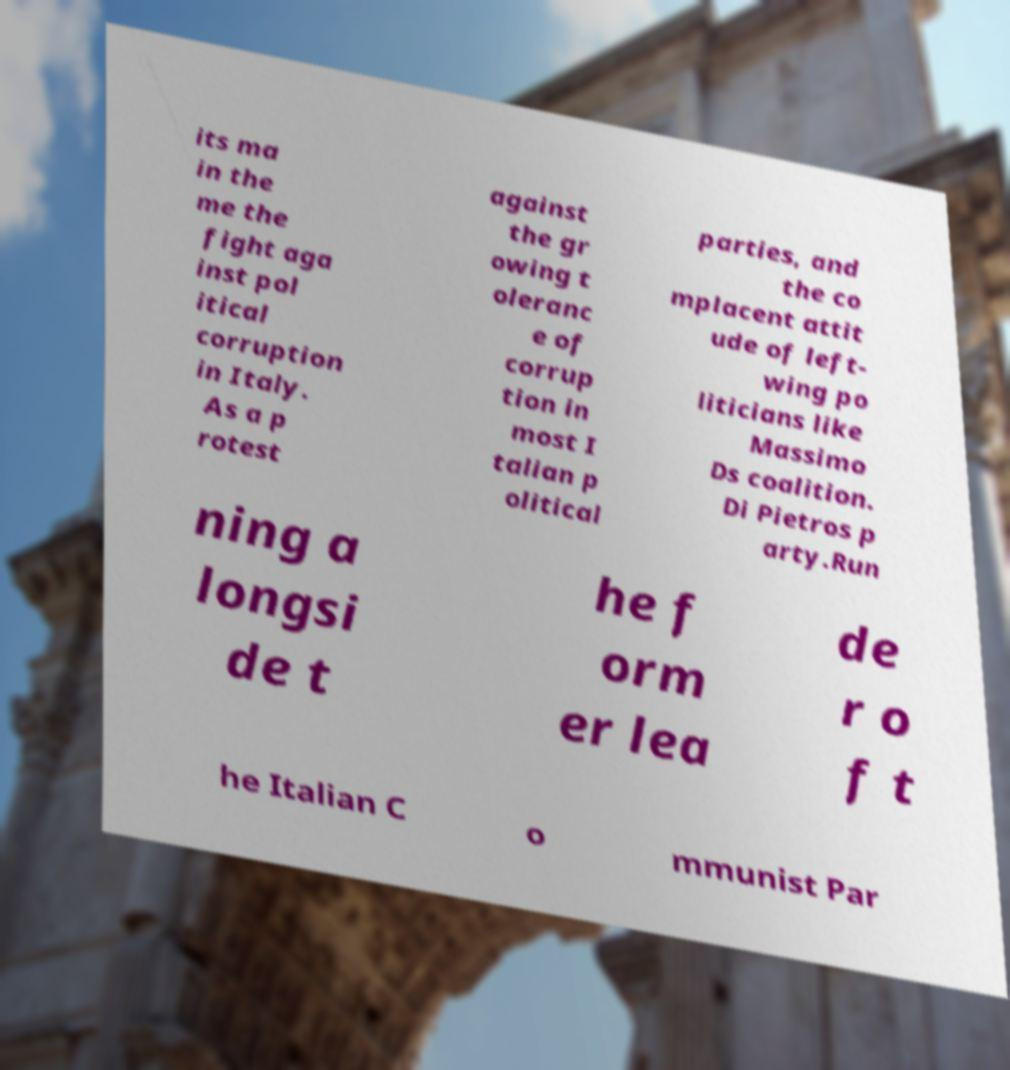Can you read and provide the text displayed in the image?This photo seems to have some interesting text. Can you extract and type it out for me? its ma in the me the fight aga inst pol itical corruption in Italy. As a p rotest against the gr owing t oleranc e of corrup tion in most I talian p olitical parties, and the co mplacent attit ude of left- wing po liticians like Massimo Ds coalition. Di Pietros p arty.Run ning a longsi de t he f orm er lea de r o f t he Italian C o mmunist Par 